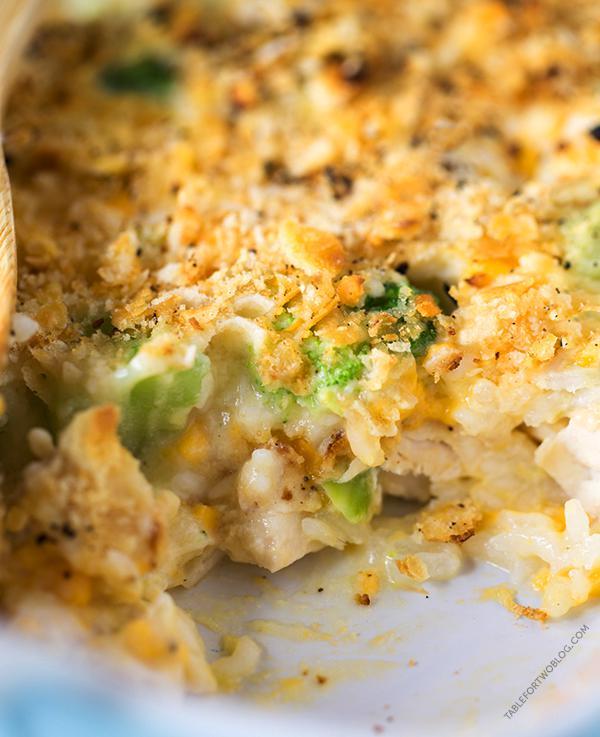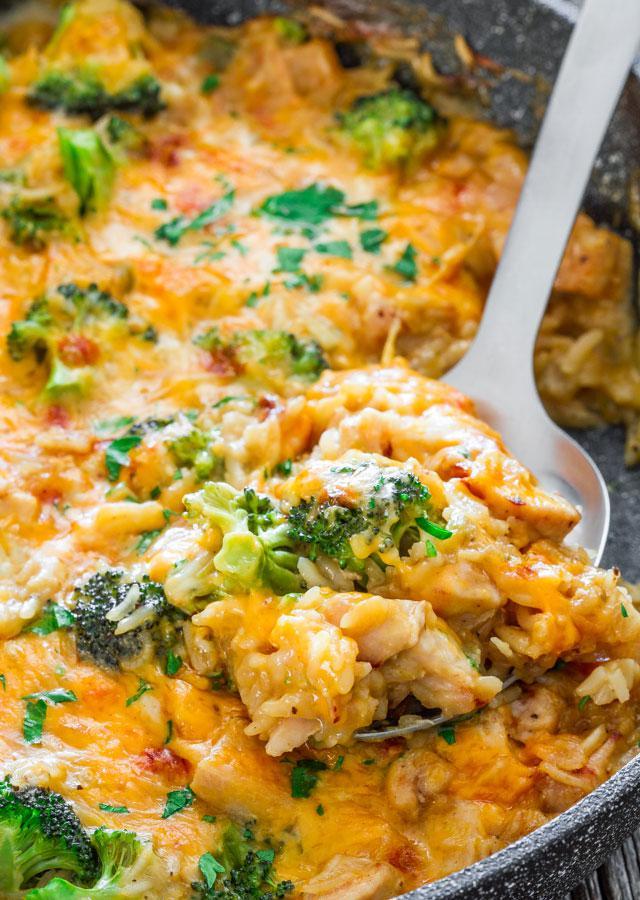The first image is the image on the left, the second image is the image on the right. Considering the images on both sides, is "In one of the images there is a broccoli casserole with a large serving spoon in it." valid? Answer yes or no. Yes. 